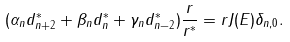<formula> <loc_0><loc_0><loc_500><loc_500>( \alpha _ { n } d _ { n + 2 } ^ { * } + \beta _ { n } d _ { n } ^ { * } + \gamma _ { n } d _ { n - 2 } ^ { * } ) \frac { r } { r ^ { * } } = r J ( E ) \delta _ { n , 0 } .</formula> 